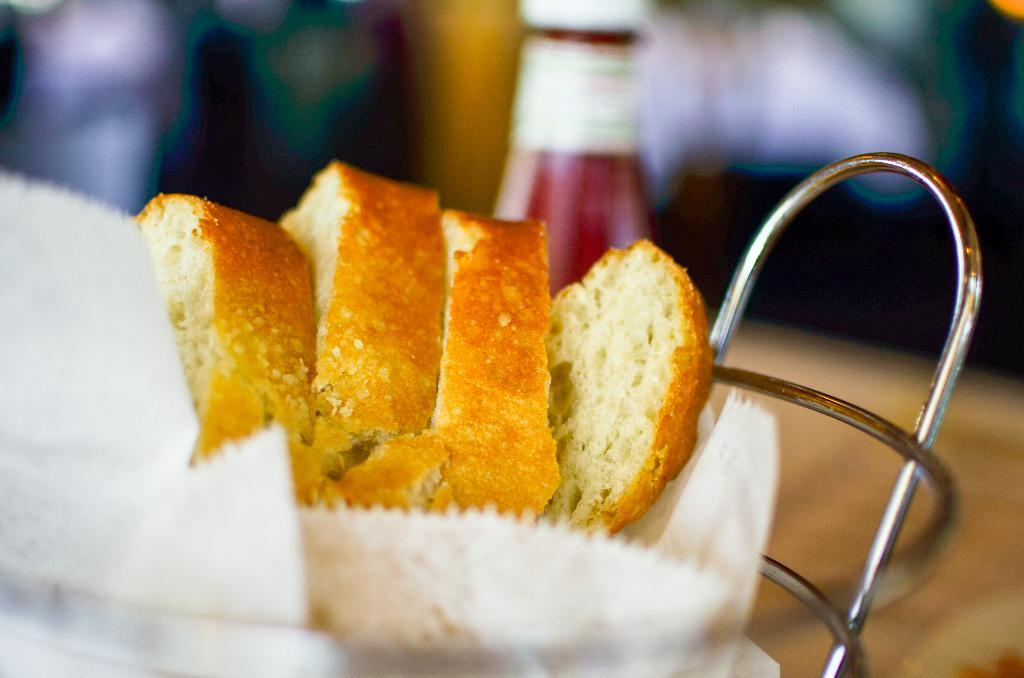What is present in the image that can be eaten? There is food in the image. What is the food placed on? The food is on an object. What else can be seen in the image besides the food? There is a bottle in the image. Can you describe the background of the image? The background of the image is blurred. What type of farm can be seen in the background of the image? There is no farm present in the image; the background is blurred. What kind of drum is being played in the image? There is no drum present in the image; it only features food, a bottle, and a blurred background. 